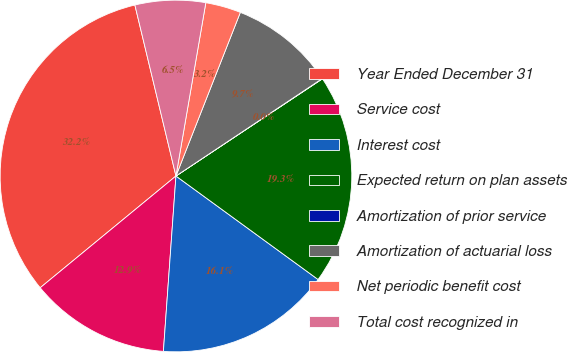Convert chart. <chart><loc_0><loc_0><loc_500><loc_500><pie_chart><fcel>Year Ended December 31<fcel>Service cost<fcel>Interest cost<fcel>Expected return on plan assets<fcel>Amortization of prior service<fcel>Amortization of actuarial loss<fcel>Net periodic benefit cost<fcel>Total cost recognized in<nl><fcel>32.21%<fcel>12.9%<fcel>16.12%<fcel>19.34%<fcel>0.03%<fcel>9.68%<fcel>3.25%<fcel>6.47%<nl></chart> 